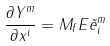<formula> <loc_0><loc_0><loc_500><loc_500>\frac { \partial Y ^ { m } } { \partial x ^ { i } } = M _ { f } E \tilde { e } ^ { m } _ { i }</formula> 